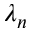Convert formula to latex. <formula><loc_0><loc_0><loc_500><loc_500>\lambda _ { n }</formula> 